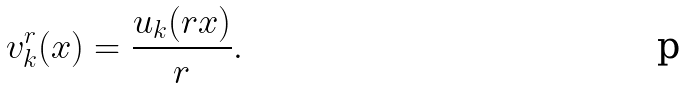<formula> <loc_0><loc_0><loc_500><loc_500>v ^ { r } _ { k } ( x ) = \frac { u _ { k } ( r x ) } { r } .</formula> 